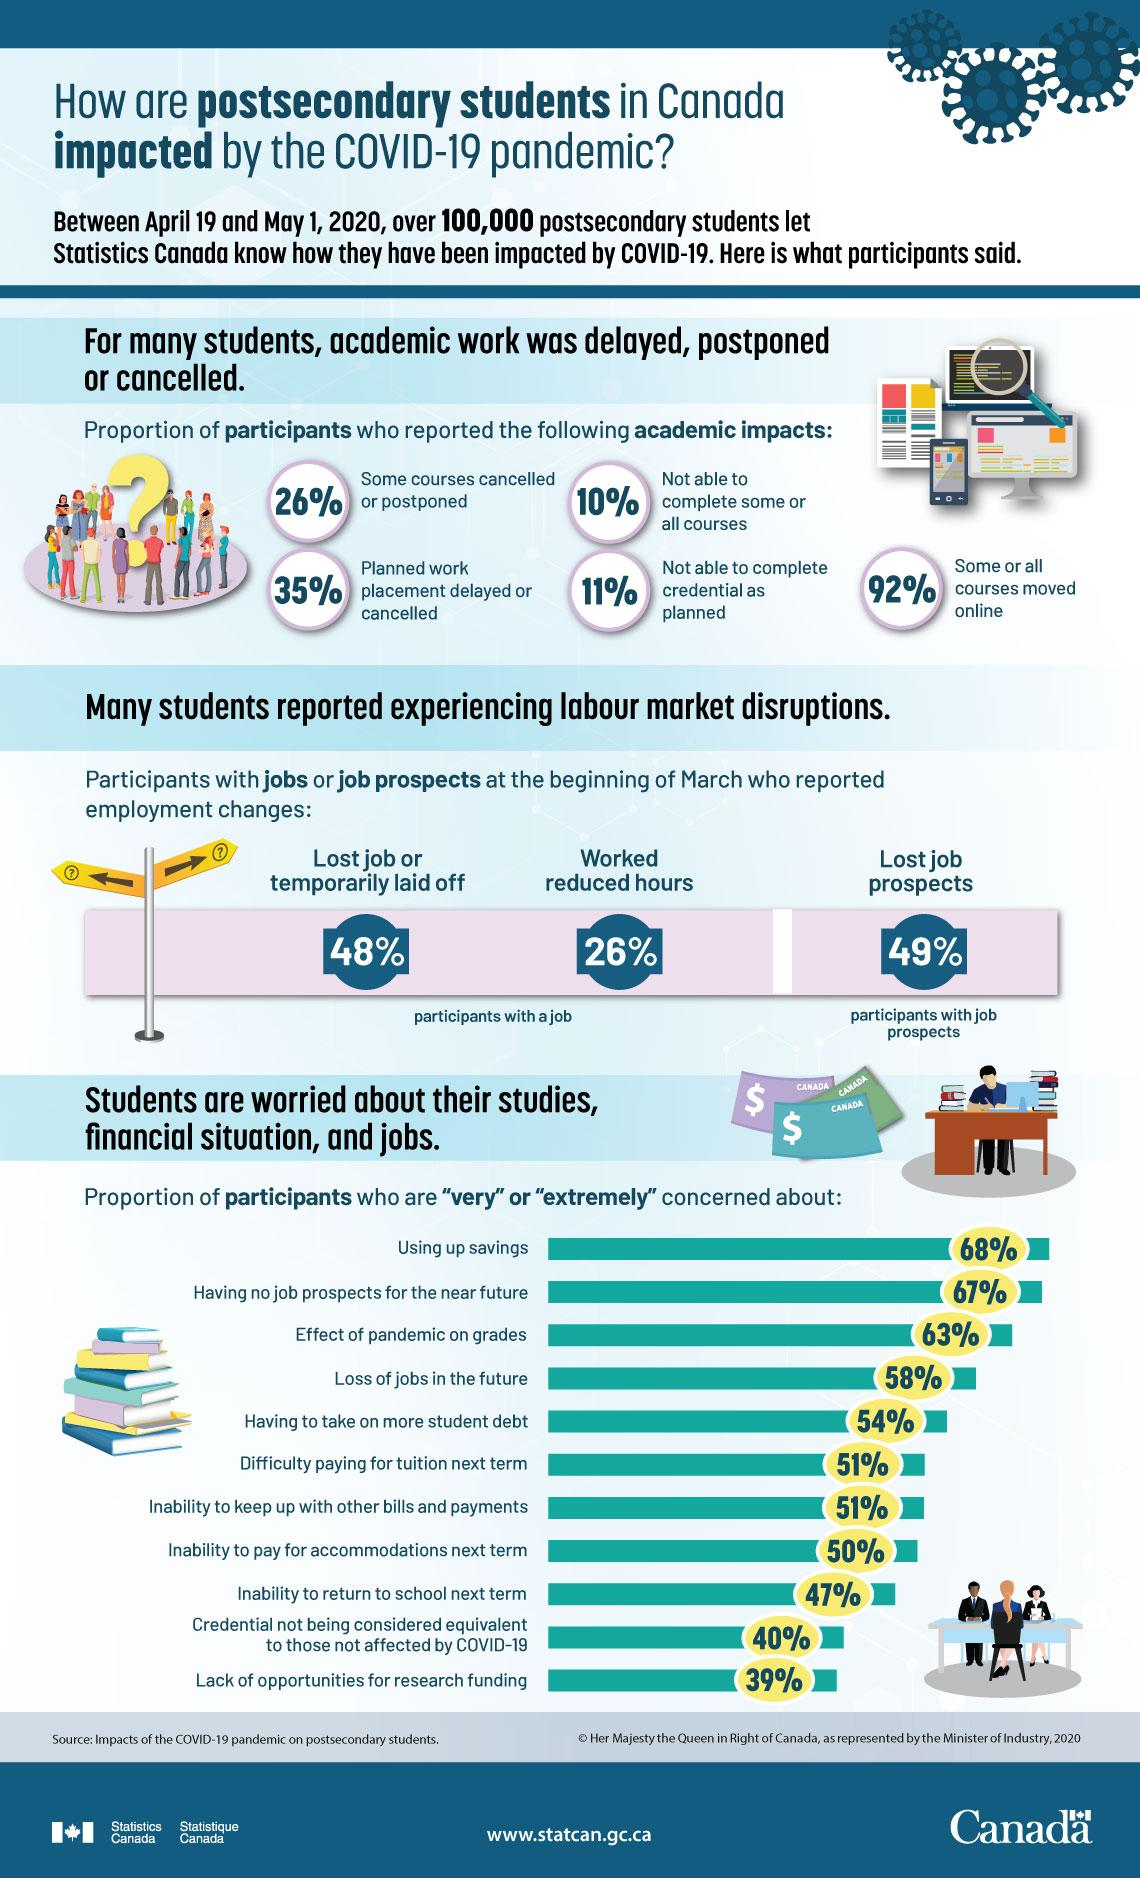Specify some key components in this picture. One of the major reasons of concern for most of the participants was the rapid depletion of their savings. A total of 32% of participants expressed no concern about their savings being depleted. As a result of the COVID-19 pandemic, 49% of participants have lost job prospects, indicating a significant impact on the employment market. According to the study, 26% of the participants worked fewer hours. According to the participants, 92% of them reported having shifted to online courses. 